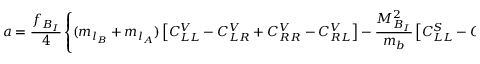Convert formula to latex. <formula><loc_0><loc_0><loc_500><loc_500>a = { \frac { f _ { B _ { I } } } { 4 } } \left \{ ( m _ { l _ { B } } + m _ { l _ { A } } ) \left [ C _ { L L } ^ { V } - C _ { L R } ^ { V } + C _ { R R } ^ { V } - C _ { R L } ^ { V } \right ] - { \frac { M _ { B _ { I } } ^ { 2 } } { m _ { b } } } \left [ C _ { L L } ^ { S } - C _ { L R } ^ { S } + C _ { R R } ^ { S } - C _ { R L } ^ { S } \right ] \right \}</formula> 